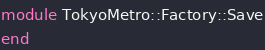<code> <loc_0><loc_0><loc_500><loc_500><_Ruby_>module TokyoMetro::Factory::Save
end</code> 